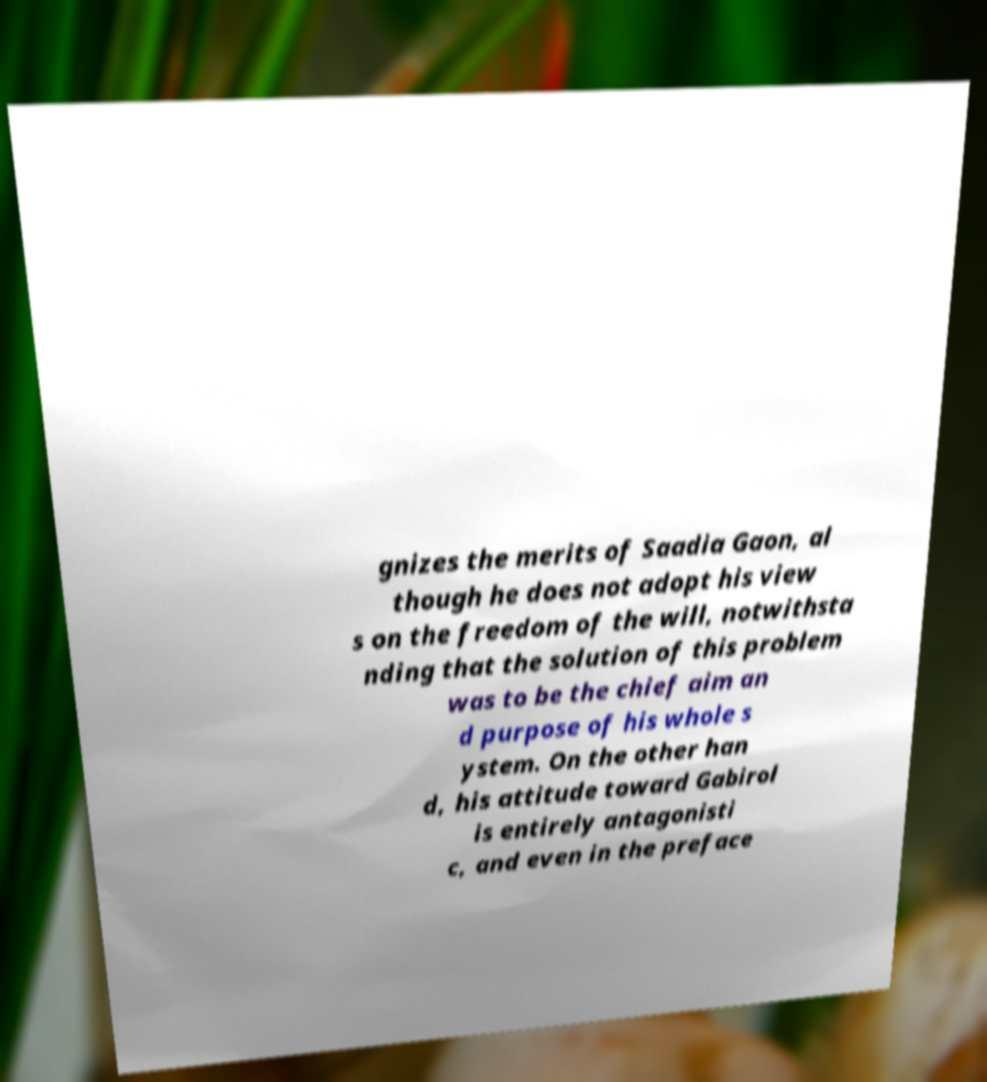Please read and relay the text visible in this image. What does it say? gnizes the merits of Saadia Gaon, al though he does not adopt his view s on the freedom of the will, notwithsta nding that the solution of this problem was to be the chief aim an d purpose of his whole s ystem. On the other han d, his attitude toward Gabirol is entirely antagonisti c, and even in the preface 